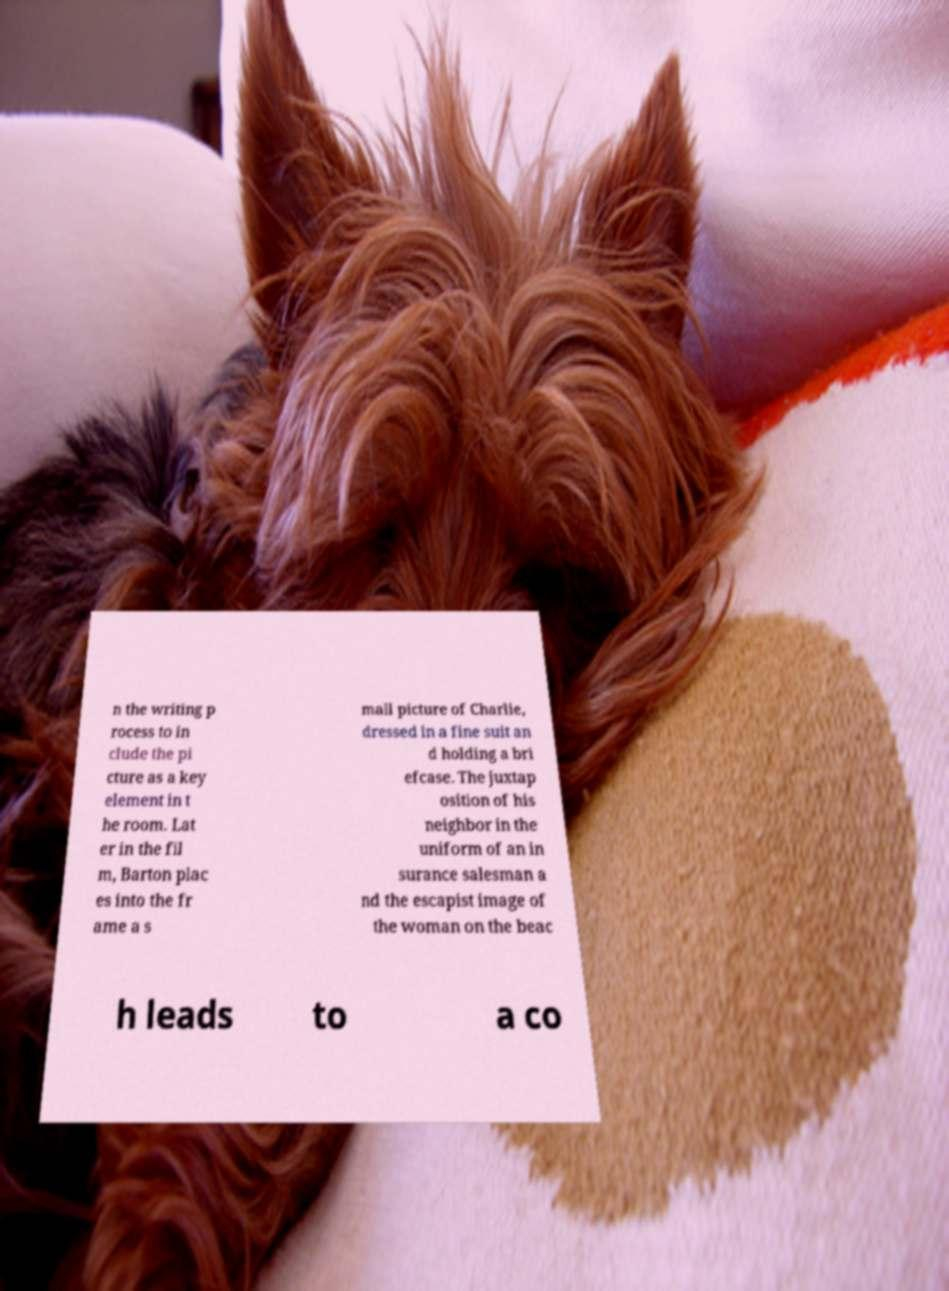Can you accurately transcribe the text from the provided image for me? n the writing p rocess to in clude the pi cture as a key element in t he room. Lat er in the fil m, Barton plac es into the fr ame a s mall picture of Charlie, dressed in a fine suit an d holding a bri efcase. The juxtap osition of his neighbor in the uniform of an in surance salesman a nd the escapist image of the woman on the beac h leads to a co 